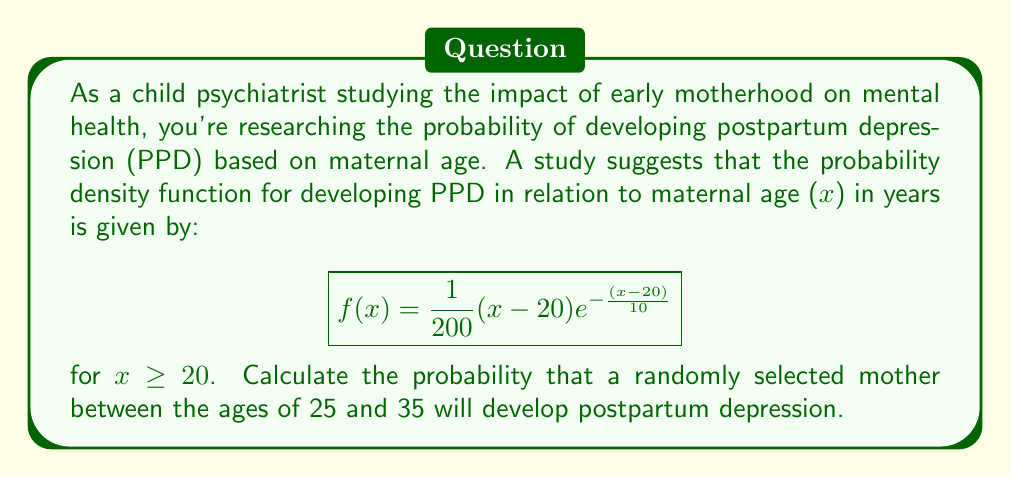Show me your answer to this math problem. To solve this problem, we need to integrate the probability density function over the given age range. The steps are as follows:

1) The probability is given by the definite integral of $f(x)$ from 25 to 35:

   $$P(25 \leq x \leq 35) = \int_{25}^{35} f(x) dx = \int_{25}^{35} \frac{1}{200}(x-20)e^{-\frac{(x-20)}{10}} dx$$

2) Let's substitute $u = \frac{x-20}{10}$. Then $du = \frac{1}{10}dx$, or $dx = 10du$.
   When $x = 25$, $u = 0.5$; when $x = 35$, $u = 1.5$.

3) Rewriting the integral:

   $$\int_{0.5}^{1.5} \frac{1}{20}u e^{-u} \cdot 10 du = \frac{1}{2}\int_{0.5}^{1.5} u e^{-u} du$$

4) We can solve this using integration by parts. Let $v = u$ and $dw = e^{-u}du$.
   Then $dv = du$ and $w = -e^{-u}$.

   $$\frac{1}{2}\left[-ue^{-u} - \int -e^{-u} du\right]_{0.5}^{1.5}$$

5) Evaluating:

   $$\frac{1}{2}\left[-ue^{-u} + e^{-u}\right]_{0.5}^{1.5}$$
   $$= \frac{1}{2}\left[(-1.5e^{-1.5} + e^{-1.5}) - (-0.5e^{-0.5} + e^{-0.5})\right]$$

6) Calculating the numerical value:

   $$\approx \frac{1}{2}(0.0847 - 0.3033) \approx -0.1093$$

7) The negative sign is due to the direction of integration. The absolute value gives the probability.
Answer: The probability that a randomly selected mother between the ages of 25 and 35 will develop postpartum depression is approximately 0.1093 or 10.93%. 